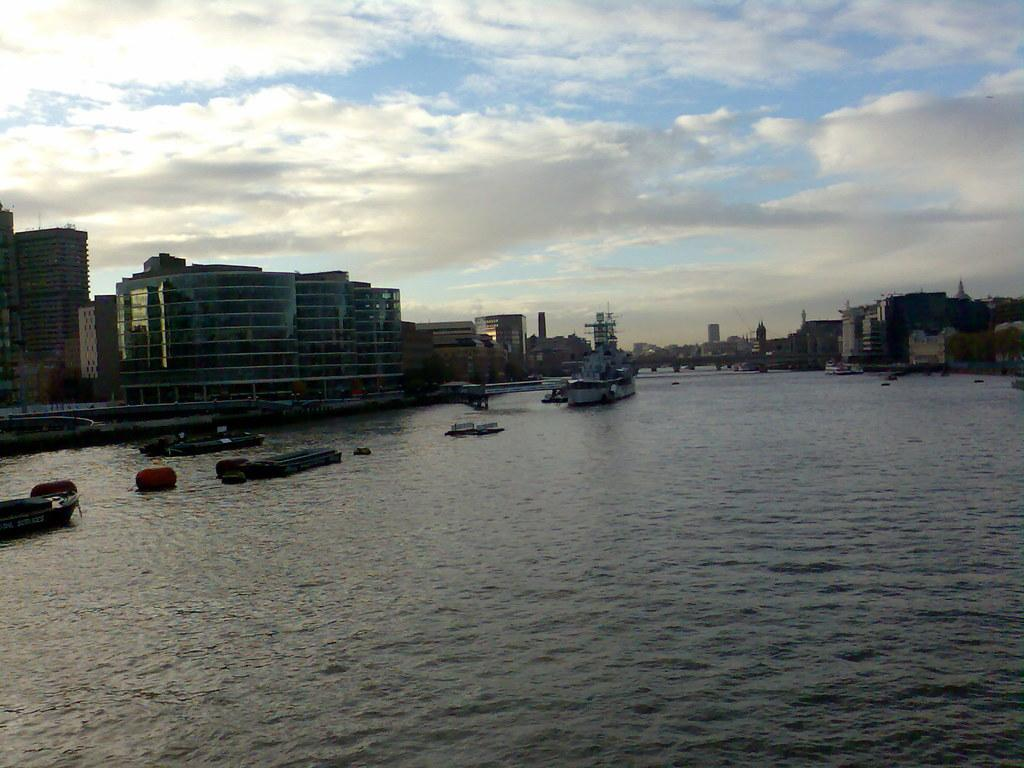What is on the surface of the water in the image? There are boats on the surface of the water in the image. What can be seen in the background of the image? There are buildings in the background of the image. What is visible at the top of the image? The sky is visible at the top of the image. What can be observed in the sky? Clouds are present in the sky. What flavor of beetle can be seen crawling on the boats in the image? There are no beetles present in the image, and therefore no flavor can be associated with them. 